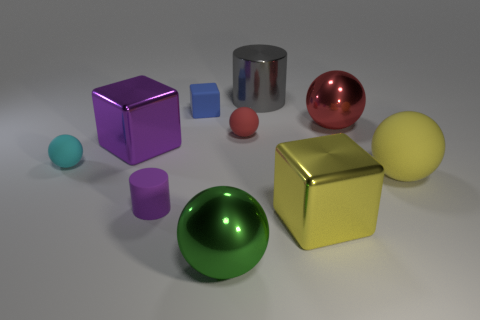Does the big purple object have the same material as the tiny object left of the tiny purple cylinder?
Make the answer very short. No. How many objects are either big objects that are behind the large yellow matte ball or rubber objects behind the large red metallic sphere?
Ensure brevity in your answer.  4. What number of other objects are there of the same color as the large rubber thing?
Provide a short and direct response. 1. Is the number of yellow rubber things that are to the left of the big gray object greater than the number of cyan spheres that are behind the tiny red matte sphere?
Provide a short and direct response. No. What number of blocks are either purple rubber things or big yellow objects?
Your answer should be very brief. 1. What number of things are big metallic objects behind the small blue rubber thing or tiny cyan shiny cylinders?
Provide a short and direct response. 1. What shape is the big metallic object that is behind the tiny matte object that is behind the red ball that is to the left of the large gray cylinder?
Provide a short and direct response. Cylinder. How many other small blue rubber things are the same shape as the tiny blue matte object?
Make the answer very short. 0. There is a big block that is the same color as the rubber cylinder; what is its material?
Your response must be concise. Metal. Do the large gray cylinder and the blue thing have the same material?
Keep it short and to the point. No. 